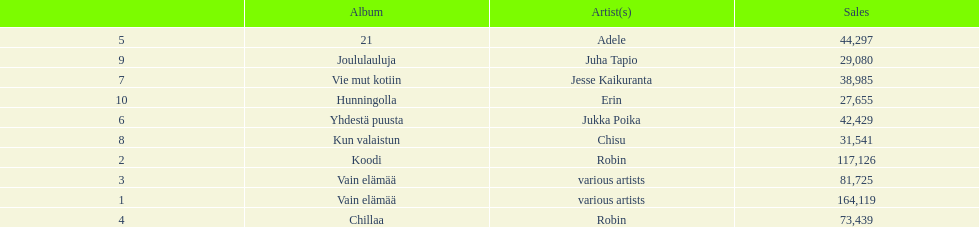Which was better selling, hunningolla or vain elamaa? Vain elämää. 